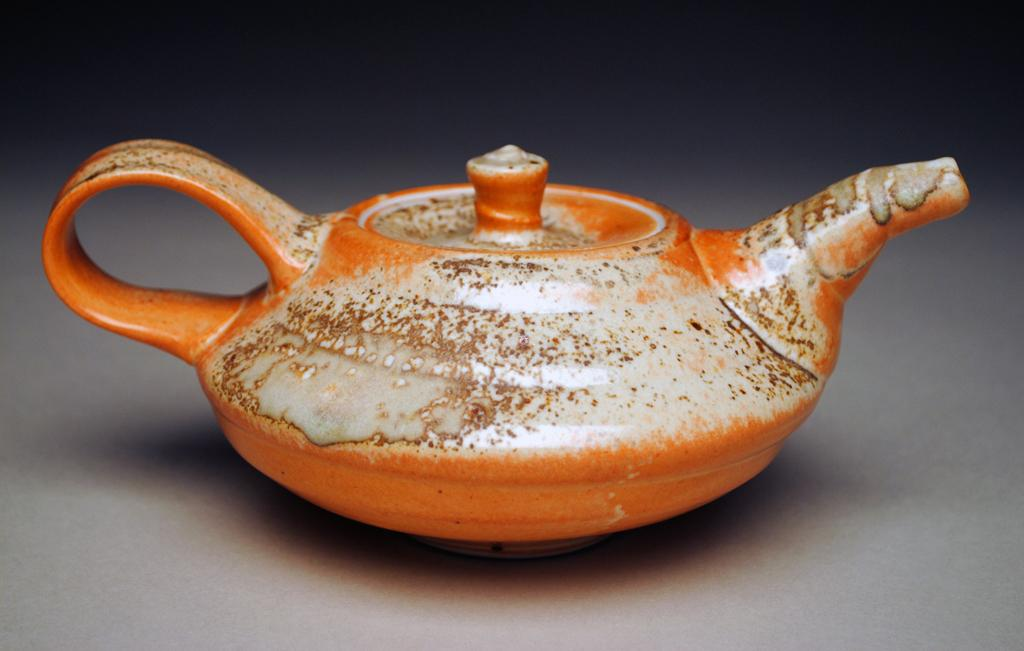What color is the teapot in the image? The teapot in the image is orange. Where is the teapot located in the image? The teapot is placed on an object in the center of the image. Are there any ants crawling on the teapot in the image? There is no mention of ants in the image, so we cannot determine if any are present. 